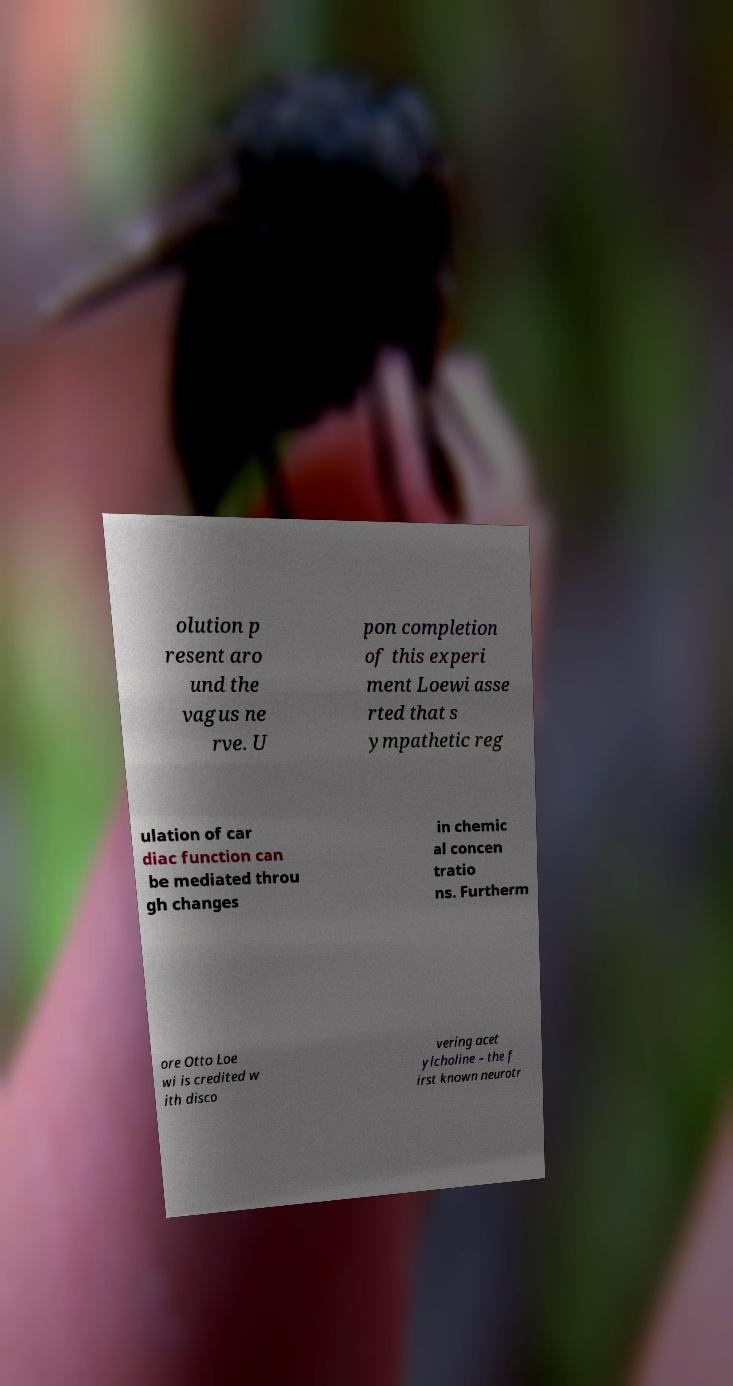I need the written content from this picture converted into text. Can you do that? olution p resent aro und the vagus ne rve. U pon completion of this experi ment Loewi asse rted that s ympathetic reg ulation of car diac function can be mediated throu gh changes in chemic al concen tratio ns. Furtherm ore Otto Loe wi is credited w ith disco vering acet ylcholine – the f irst known neurotr 